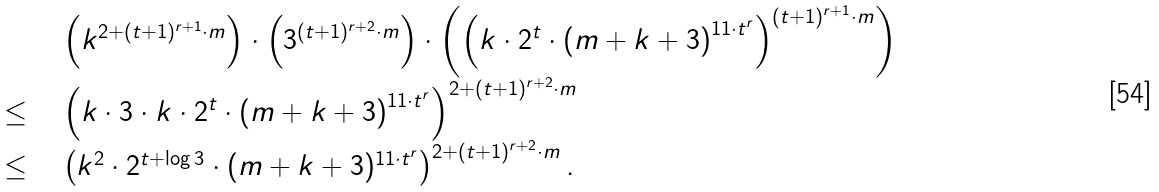<formula> <loc_0><loc_0><loc_500><loc_500>\begin{array} [ b ] { l l } & \left ( k ^ { 2 + ( t + 1 ) ^ { r + 1 } \cdot m } \right ) \cdot \left ( 3 ^ { ( t + 1 ) ^ { r + 2 } \cdot m } \right ) \cdot \left ( \left ( k \cdot 2 ^ { t } \cdot \left ( m + k + 3 \right ) ^ { 1 1 \cdot t ^ { r } } \right ) ^ { ( t + 1 ) ^ { r + 1 } \cdot m } \right ) \\ \leq \ \ & \left ( k \cdot 3 \cdot k \cdot 2 ^ { t } \cdot \left ( m + k + 3 \right ) ^ { 1 1 \cdot t ^ { r } } \right ) ^ { 2 + ( t + 1 ) ^ { r + 2 } \cdot m } \\ \leq \ \ & \left ( k ^ { 2 } \cdot 2 ^ { t + \log 3 } \cdot ( m + k + 3 ) ^ { 1 1 \cdot t ^ { r } } \right ) ^ { 2 + ( t + 1 ) ^ { r + 2 } \cdot m } . \end{array}</formula> 